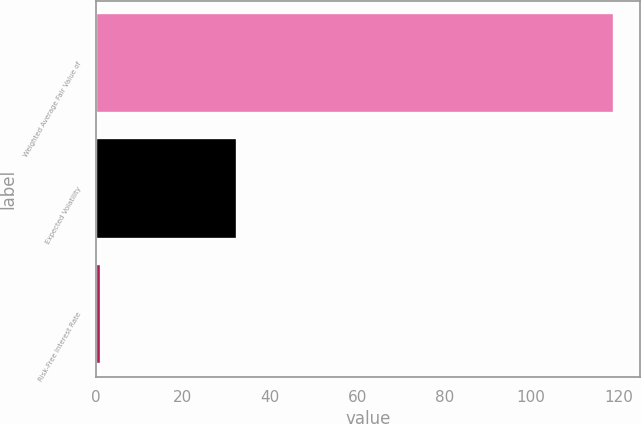Convert chart to OTSL. <chart><loc_0><loc_0><loc_500><loc_500><bar_chart><fcel>Weighted Average Fair Value of<fcel>Expected Volatility<fcel>Risk-Free Interest Rate<nl><fcel>119.1<fcel>32.48<fcel>1.15<nl></chart> 